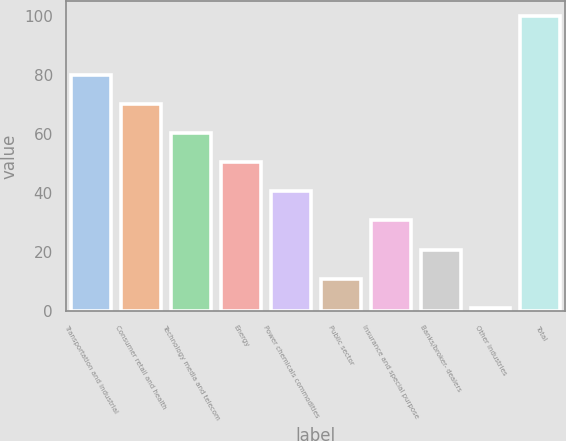Convert chart to OTSL. <chart><loc_0><loc_0><loc_500><loc_500><bar_chart><fcel>Transportation and industrial<fcel>Consumer retail and health<fcel>Technology media and telecom<fcel>Energy<fcel>Power chemicals commodities<fcel>Public sector<fcel>Insurance and special purpose<fcel>Banks/broker- dealers<fcel>Other industries<fcel>Total<nl><fcel>80.2<fcel>70.3<fcel>60.4<fcel>50.5<fcel>40.6<fcel>10.9<fcel>30.7<fcel>20.8<fcel>1<fcel>100<nl></chart> 